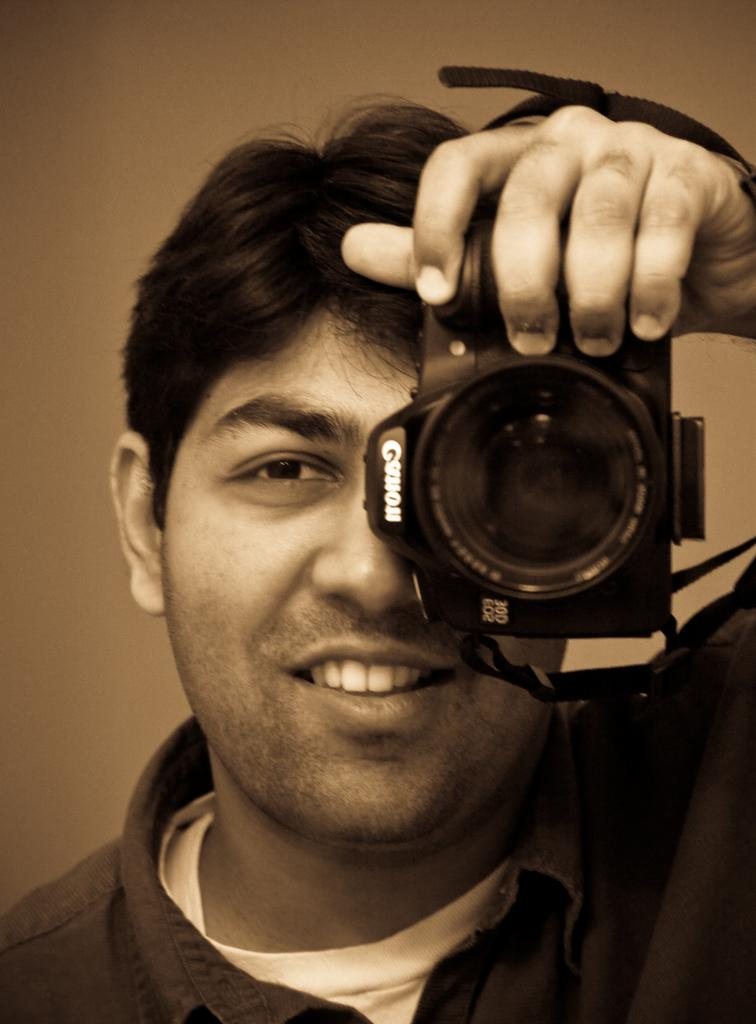Who is present in the image? There is a man in the image. What is the man doing in the image? The man is smiling in the image. What is the man holding in his hands? The man is holding a camera in his hands. What brand of camera is the man holding? The camera is from the Canon company. What type of plantation can be seen in the background of the image? There is no plantation visible in the image; it only features a man holding a Canon camera. How many tomatoes are on the list in the image? There is no list or tomatoes present in the image. 